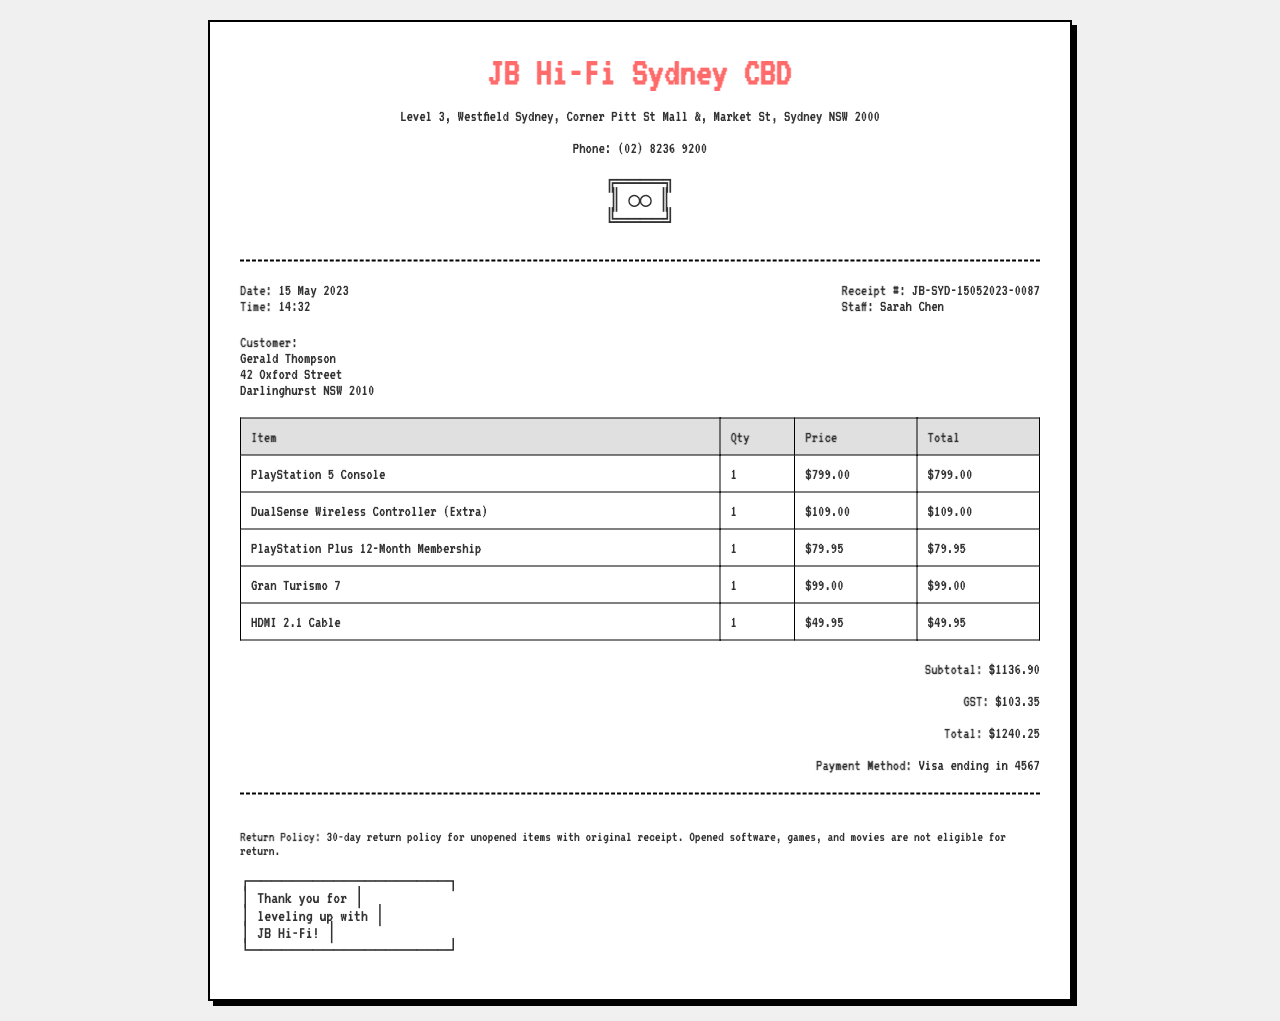what is the date of purchase? The date of purchase is indicated in the document under the store information section.
Answer: 15 May 2023 who is the staff member that assisted with the purchase? The staff member's name is mentioned in the store information section.
Answer: Sarah Chen what is the total amount paid? The total amount paid is provided in the total section at the end of the document.
Answer: $1240.25 how many items were purchased? The total number of items can be calculated from the items table, counting each line item listed.
Answer: 5 what is the payment method used? The payment method is stated in the total section of the receipt.
Answer: Visa ending in 4567 what is the subtotal before GST? The subtotal is listed in the total section prior to the GST addition.
Answer: $1136.90 what is the return policy for unopened items? The return policy is outlined in the footer of the receipt regarding unopened items.
Answer: 30-day return policy which item has the highest price? The prices of the items can be compared in the items table to identify the highest.
Answer: PlayStation 5 Console what is the address of the store? The store's address is provided in the header of the document.
Answer: Level 3, Westfield Sydney, Corner Pitt St Mall &, Market St, Sydney NSW 2000 